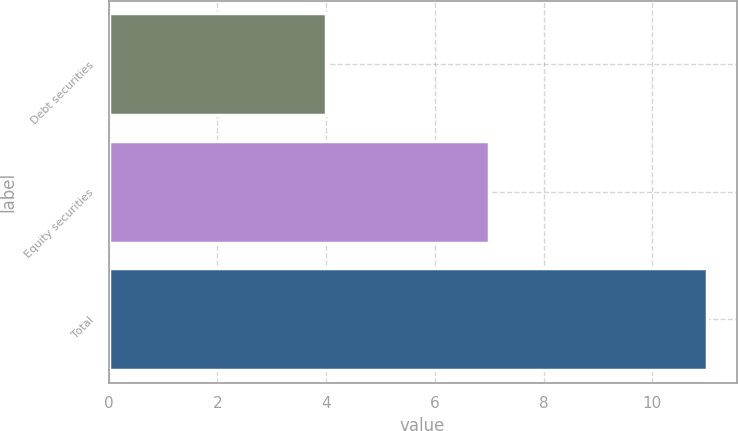Convert chart. <chart><loc_0><loc_0><loc_500><loc_500><bar_chart><fcel>Debt securities<fcel>Equity securities<fcel>Total<nl><fcel>4<fcel>7<fcel>11<nl></chart> 